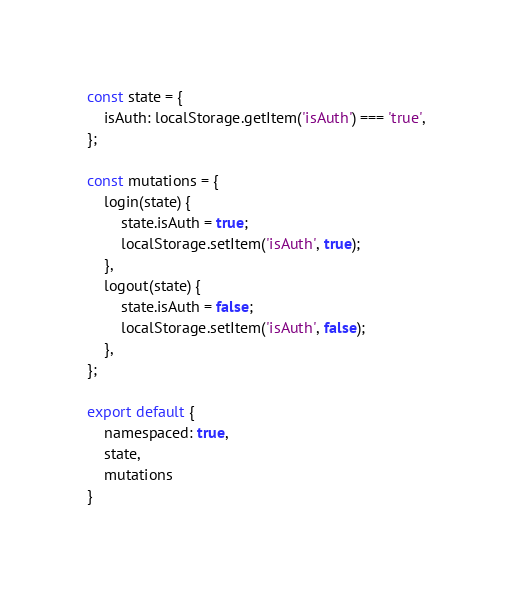<code> <loc_0><loc_0><loc_500><loc_500><_JavaScript_>const state = {
    isAuth: localStorage.getItem('isAuth') === 'true',
};

const mutations = {
    login(state) {
        state.isAuth = true;
        localStorage.setItem('isAuth', true);
    },
    logout(state) {
        state.isAuth = false;
        localStorage.setItem('isAuth', false);
    },
};

export default {
    namespaced: true,
    state,
    mutations
}</code> 